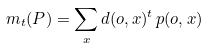Convert formula to latex. <formula><loc_0><loc_0><loc_500><loc_500>m _ { t } ( P ) = \sum _ { x } d ( o , x ) ^ { t } \, p ( o , x )</formula> 